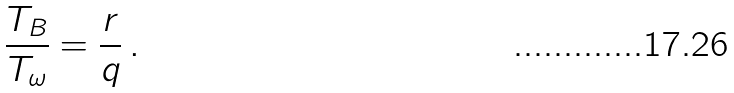Convert formula to latex. <formula><loc_0><loc_0><loc_500><loc_500>\frac { T _ { B } } { T _ { \omega } } = \frac { r } { q } \, .</formula> 